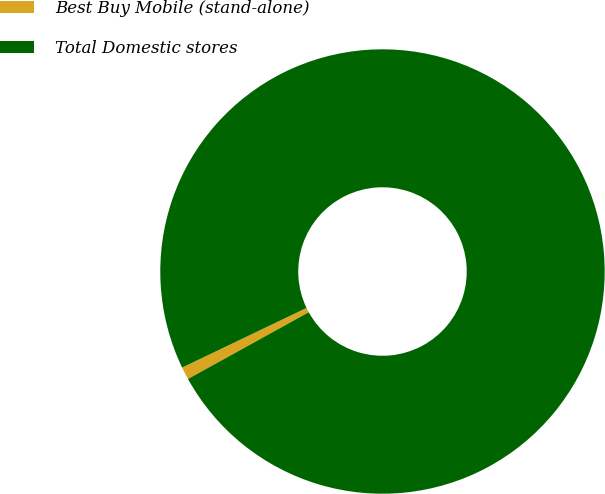Convert chart. <chart><loc_0><loc_0><loc_500><loc_500><pie_chart><fcel>Best Buy Mobile (stand-alone)<fcel>Total Domestic stores<nl><fcel>0.92%<fcel>99.08%<nl></chart> 